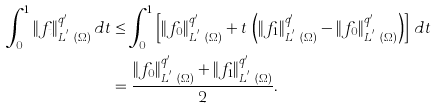Convert formula to latex. <formula><loc_0><loc_0><loc_500><loc_500>\int _ { 0 } ^ { 1 } \| f _ { t } \| ^ { q ^ { \prime } } _ { L ^ { q ^ { \prime } } ( \Omega ) } \, d t & \leq \int _ { 0 } ^ { 1 } \left [ \| f _ { 0 } \| ^ { q ^ { \prime } } _ { L ^ { q ^ { \prime } } ( \Omega ) } + t \, \left ( \| f _ { 1 } \| ^ { q ^ { \prime } } _ { L ^ { q ^ { \prime } } ( \Omega ) } - \| f _ { 0 } \| ^ { q ^ { \prime } } _ { L ^ { q ^ { \prime } } ( \Omega ) } \right ) \right ] \, d t \\ & = \frac { \| f _ { 0 } \| ^ { q ^ { \prime } } _ { L ^ { q ^ { \prime } } ( \Omega ) } + \| f _ { 1 } \| ^ { q ^ { \prime } } _ { L ^ { q ^ { \prime } } ( \Omega ) } } { 2 } .</formula> 